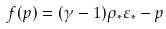<formula> <loc_0><loc_0><loc_500><loc_500>f ( p ) = ( \gamma - 1 ) \rho _ { \ast } \varepsilon _ { \ast } - p</formula> 